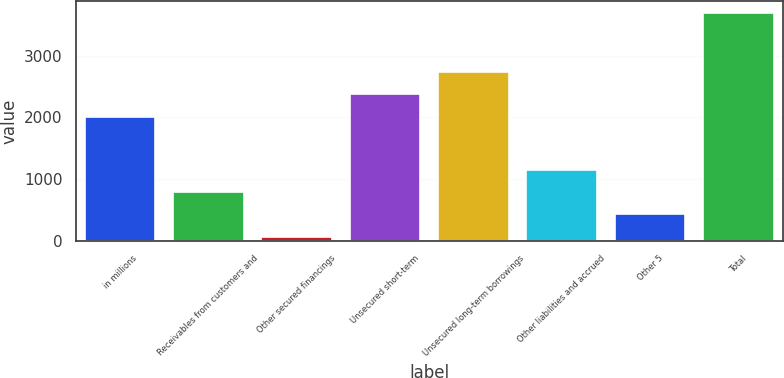Convert chart to OTSL. <chart><loc_0><loc_0><loc_500><loc_500><bar_chart><fcel>in millions<fcel>Receivables from customers and<fcel>Other secured financings<fcel>Unsecured short-term<fcel>Unsecured long-term borrowings<fcel>Other liabilities and accrued<fcel>Other 5<fcel>Total<nl><fcel>2011<fcel>790<fcel>63<fcel>2374.5<fcel>2738<fcel>1153.5<fcel>426.5<fcel>3698<nl></chart> 